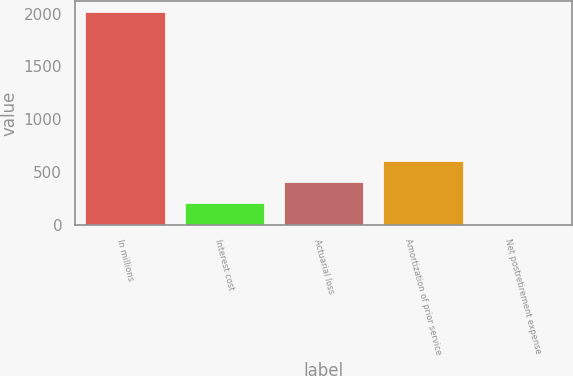<chart> <loc_0><loc_0><loc_500><loc_500><bar_chart><fcel>In millions<fcel>Interest cost<fcel>Actuarial loss<fcel>Amortization of prior service<fcel>Net postretirement expense<nl><fcel>2017<fcel>202.6<fcel>404.2<fcel>605.8<fcel>1<nl></chart> 